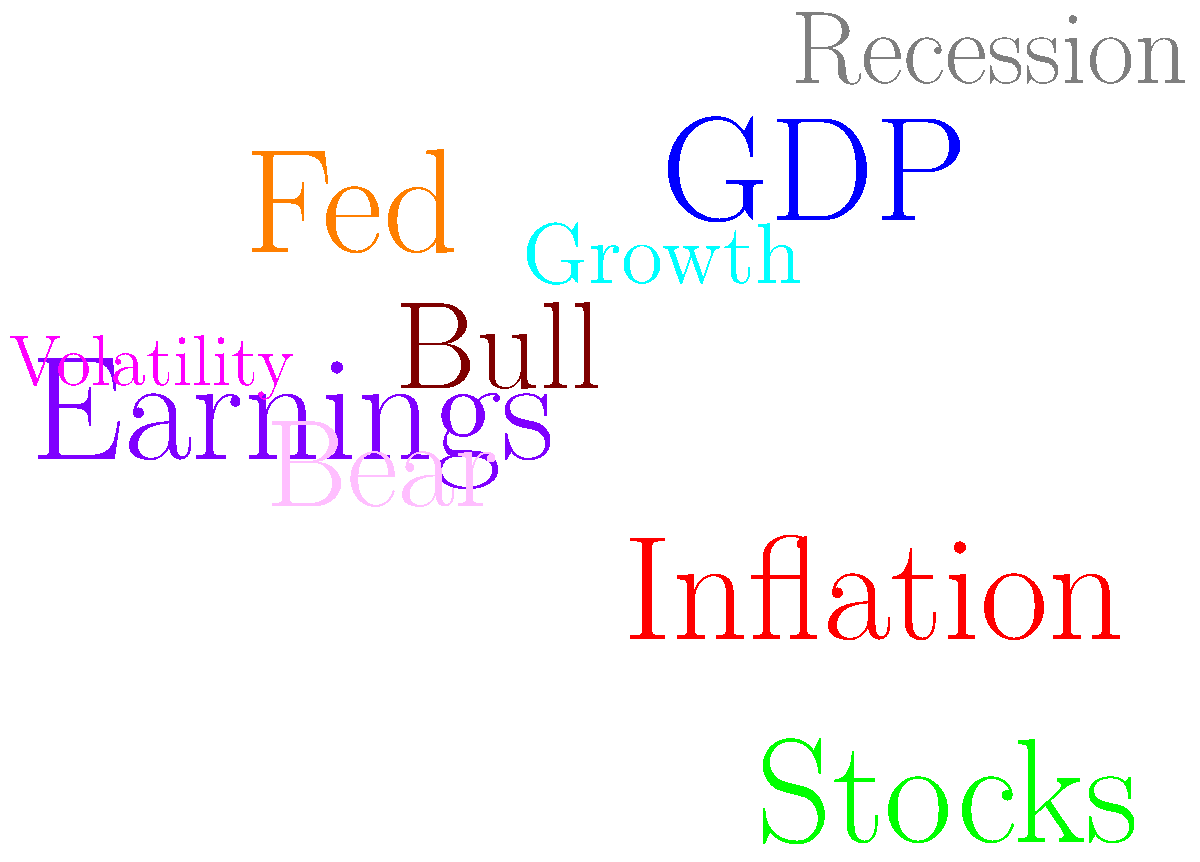Based on the word cloud of financial news headlines, which market sentiment indicator appears to be the most prominent, and how might this influence your investment strategy? To analyze the word cloud and determine the most prominent market sentiment indicator:

1. Identify the largest word: "Inflation" stands out as the largest and most eye-catching term.

2. Consider the implications:
   a) High inflation often leads to increased interest rates.
   b) It can negatively impact bond prices and fixed-income investments.
   c) Certain sectors, like consumer staples or real estate, may be more affected.

3. Analyze related terms:
   - "GDP" and "Growth" suggest economic concerns.
   - "Fed" implies potential monetary policy changes.
   - "Volatility" indicates market uncertainty.

4. Evaluate market direction indicators:
   - "Bull" and "Bear" are present, but smaller, suggesting mixed sentiment.

5. Consider earnings impact:
   - "Earnings" is moderately sized, indicating its importance in the current climate.

6. Develop an investment strategy:
   a) Focus on inflation-resistant assets (e.g., TIPS, commodities).
   b) Consider value stocks over growth stocks.
   c) Be cautious with long-term bonds.
   d) Look for companies with pricing power.
   e) Monitor Fed actions closely for potential market impacts.

Given the prominence of "Inflation," the optimal strategy would be to prioritize inflation-hedging investments while carefully monitoring economic indicators and Fed policies.
Answer: Inflation; prioritize inflation-hedging investments. 